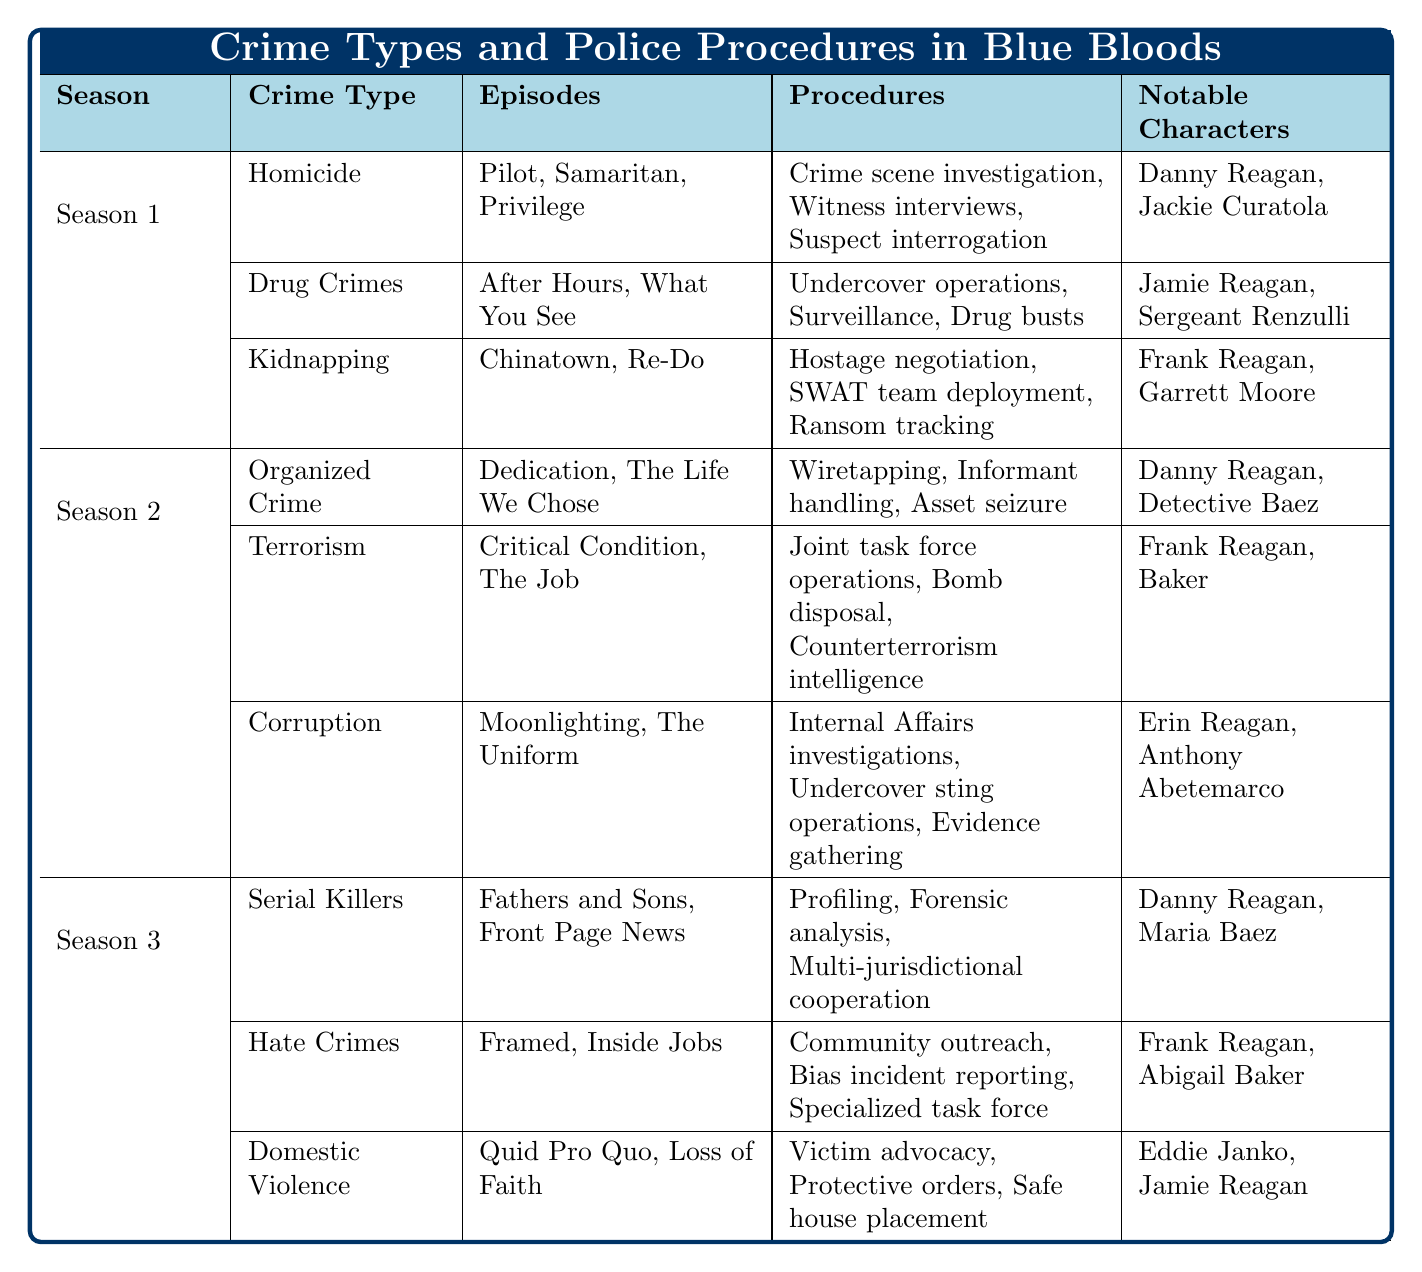What crime type featured the most episodes in Season 1? "Homicide," "Drug Crimes," and "Kidnapping" all have 3 episodes. However, since they are tied, we can state that each of these crime types featured the same number of episodes in Season 1.
Answer: Homicide, Drug Crimes, Kidnapping Which notable character appeared in both Season 1 and Season 3? "Danny Reagan" is listed under both "Homicide" in Season 1 and "Serial Killers" in Season 3, indicating that he appears in both seasons.
Answer: Danny Reagan How many unique crime types are listed across all three seasons? Counting the unique crime types: Homicide, Drug Crimes, Kidnapping, Organized Crime, Terrorism, Corruption, Serial Killers, Hate Crimes, Domestic Violence gives us a total of 9 unique types.
Answer: 9 Which season had episodes related to terrorism? The table indicates that terrorism is mentioned in Season 2 under the crime type "Terrorism."
Answer: Season 2 If you combine the episodes from "Corruption" and "Kidnapping," how many episodes are there altogether? "Corruption" has 2 episodes and "Kidnapping" has 2 episodes, adding them together gives us 2 + 2 = 4 episodes in total.
Answer: 4 Did any notable characters appear in episodes about both organized crime and serial killers? "Danny Reagan" is a notable character in Season 2's organized crime episodes and Season 3's serial killer episodes, confirming his presence in both categories.
Answer: Yes What procedures are associated with hate crimes? The procedures linked to hate crimes include "Community outreach," "Bias incident reporting," and "Specialized task force."
Answer: Community outreach, Bias incident reporting, Specialized task force How many notable characters are associated with drug crimes in Season 1? "Jamie Reagan" and "Sergeant Renzulli" are the notable characters listed under drug crimes in Season 1, totaling 2 characters.
Answer: 2 Which crime type has the least number of episodes in Season 2? "Corruption," with 2 episodes, is the crime type with the least episodes in Season 2, compared to Organized Crime and Terrorism, which have 2 episodes each. Hence, they are tied with Corruption.
Answer: Corruption Which crime type procedures involve hostage negotiation? The procedures associated with "Kidnapping" include "Hostage negotiation," which is specific to that crime type.
Answer: Kidnapping 